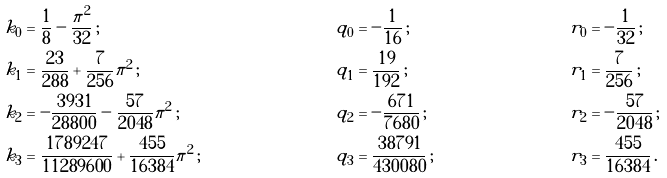<formula> <loc_0><loc_0><loc_500><loc_500>k _ { 0 } & = \frac { 1 } { 8 } - \frac { \pi ^ { 2 } } { 3 2 } \, ; & q _ { 0 } & = - \frac { 1 } { 1 6 } \, ; & r _ { 0 } & = - \frac { 1 } { 3 2 } \, ; \\ k _ { 1 } & = \frac { 2 3 } { 2 8 8 } + \frac { 7 } { 2 5 6 } \pi ^ { 2 } \, ; & q _ { 1 } & = \frac { 1 9 } { 1 9 2 } \, ; & r _ { 1 } & = \frac { 7 } { 2 5 6 } \, ; \\ k _ { 2 } & = - \frac { 3 9 3 1 } { 2 8 8 0 0 } - \frac { 5 7 } { 2 0 4 8 } \pi ^ { 2 } \, ; & q _ { 2 } & = - \frac { 6 7 1 } { 7 6 8 0 } \, ; & r _ { 2 } & = - \frac { 5 7 } { 2 0 4 8 } \, ; \\ k _ { 3 } & = \frac { 1 7 8 9 2 4 7 } { 1 1 2 8 9 6 0 0 } + \frac { 4 5 5 } { 1 6 3 8 4 } \pi ^ { 2 } \, ; & q _ { 3 } & = \frac { 3 8 7 9 1 } { 4 3 0 0 8 0 } \, ; & r _ { 3 } & = \frac { 4 5 5 } { 1 6 3 8 4 } \, .</formula> 